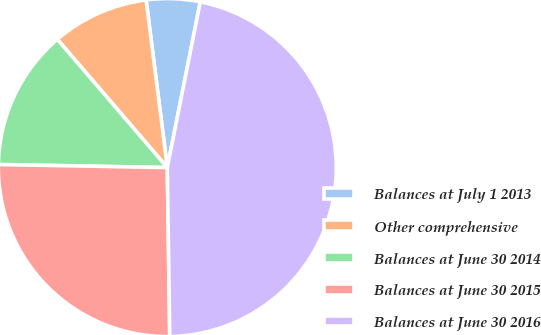Convert chart to OTSL. <chart><loc_0><loc_0><loc_500><loc_500><pie_chart><fcel>Balances at July 1 2013<fcel>Other comprehensive<fcel>Balances at June 30 2014<fcel>Balances at June 30 2015<fcel>Balances at June 30 2016<nl><fcel>5.13%<fcel>9.28%<fcel>13.43%<fcel>25.52%<fcel>46.64%<nl></chart> 